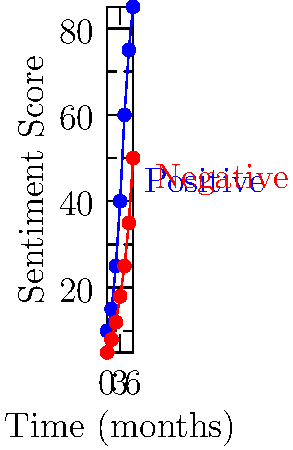Based on the social media sentiment trend visualization, what policy area should be prioritized for immediate action to address constituent concerns? To determine the policy area that requires immediate action, we need to analyze the trends in both positive and negative sentiment:

1. Observe the trends: Both positive and negative sentiment scores are increasing over time.

2. Compare growth rates: The positive sentiment (blue line) is growing at a faster rate than the negative sentiment (red line).

3. Analyze the gap: Despite the faster growth of positive sentiment, there's still a significant gap between positive and negative scores.

4. Interpret the data: The increasing sentiment scores suggest growing public engagement on a particular issue.

5. Consider political implications: As a member of parliament, addressing issues with high public engagement is crucial.

6. Evaluate urgency: The widening gap between positive and negative sentiment indicates a polarizing issue that needs attention.

7. Conclusion: The policy area represented by this data requires immediate action to address the growing divide in public opinion and capitalize on the increasing positive sentiment.
Answer: The policy area showing increasing engagement and a widening sentiment gap 